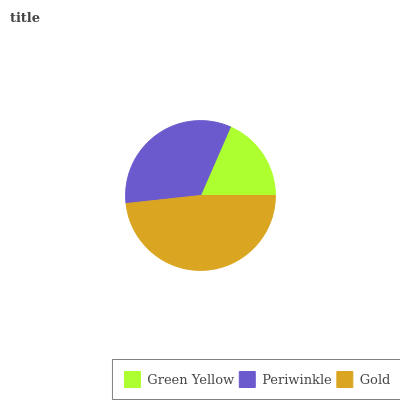Is Green Yellow the minimum?
Answer yes or no. Yes. Is Gold the maximum?
Answer yes or no. Yes. Is Periwinkle the minimum?
Answer yes or no. No. Is Periwinkle the maximum?
Answer yes or no. No. Is Periwinkle greater than Green Yellow?
Answer yes or no. Yes. Is Green Yellow less than Periwinkle?
Answer yes or no. Yes. Is Green Yellow greater than Periwinkle?
Answer yes or no. No. Is Periwinkle less than Green Yellow?
Answer yes or no. No. Is Periwinkle the high median?
Answer yes or no. Yes. Is Periwinkle the low median?
Answer yes or no. Yes. Is Green Yellow the high median?
Answer yes or no. No. Is Green Yellow the low median?
Answer yes or no. No. 